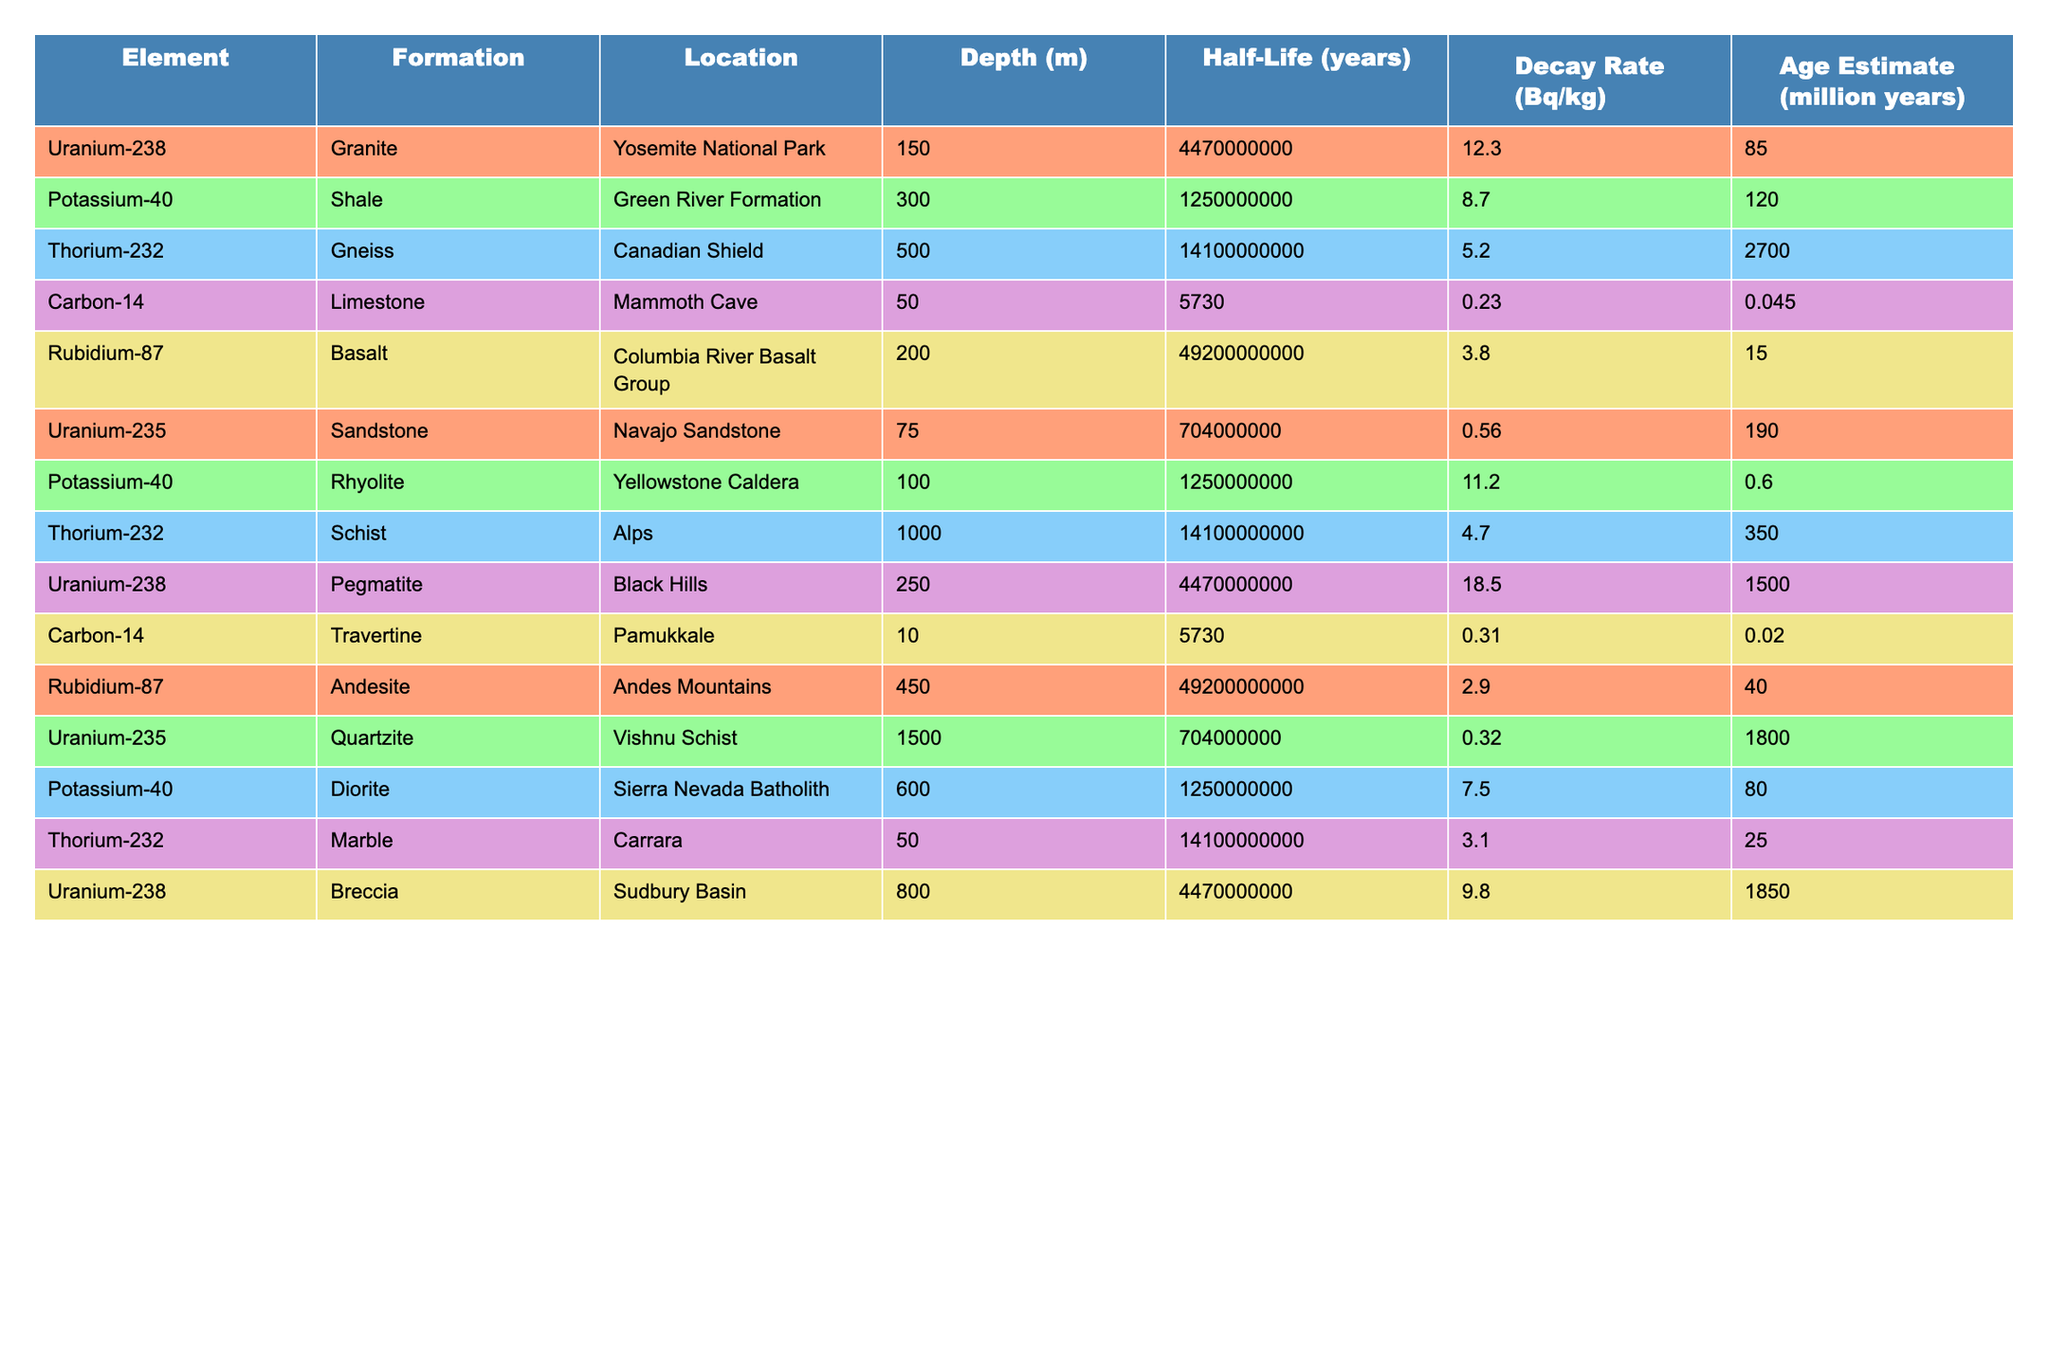What is the decay rate of Uranium-238 in the Granite formation? In the table, I find the row for Uranium-238 under the Granite formation. The decay rate associated with that entry is 12.3 Bq/kg.
Answer: 12.3 Bq/kg Which geological formation has the highest decay rate? I look through the decay rates listed for all formations, comparing them. The highest value is found for Uranium-238 in Pegmatite, which has a decay rate of 18.5 Bq/kg.
Answer: Pegmatite What is the half-life of Potassium-40? I locate the row for Potassium-40 in the table. Its corresponding half-life is listed as 1.25e9 years.
Answer: 1.25e9 years Is Carbon-14 present in the Limestone formation? I check the table for the Carbon-14 entry and find it listed under the Limestone formation with a decay rate of 0.23 Bq/kg. Therefore, the answer is yes.
Answer: Yes How much older is the Thorium-232 in Gneiss compared to the same element in Schist? I find the age estimates for Thorium-232 in the Gneiss (2700 million years) and Schist (350 million years). I calculate the difference by subtracting 350 from 2700, which gives 2350 million years as the age difference.
Answer: 2350 million years What is the average decay rate of Rubidium-87 across its two geological formations? I find the decay rates for Rubidium-87 in two formations: 3.8 Bq/kg (Basalt) and 2.9 Bq/kg (Andesite). Adding them gives 6.7 Bq/kg. Dividing by 2 (the number of formations) results in an average decay rate of 3.35 Bq/kg.
Answer: 3.35 Bq/kg Which element has the longest half-life, and what is it? I examine the half-lives for all elements in the table, focusing specifically on the longest ones. The longest half-life appears to be 4.92e10 years for Rubidium-87. I confirm that no other element has a longer listed half-life than this.
Answer: Rubidium-87 Which geological formation contains the youngest estimated age? I review the age estimates, noting that Carbon-14 in Travertine has the youngest estimate of 0.02 million years. Comparing all other entries confirms this is the lowest value listed.
Answer: Travertine How many formations have a decay rate higher than 10 Bq/kg? I inspect each decay rate and find that Uranium-238 in Granite, Pegmatite, and Schist, as well as Potassium-40 in Rhyolite, exceed 10 Bq/kg. Counting these gives a total of four such formations.
Answer: 4 Is there a formation where Potassium-40 has a decay rate less than 10 Bq/kg? I check the table entries for Potassium-40. The decay rates in Shale (8.7 Bq/kg) and Diorite (7.5 Bq/kg) are both below 10 Bq/kg. Therefore, the answer is yes, since there are formations that meet this criterion.
Answer: Yes 